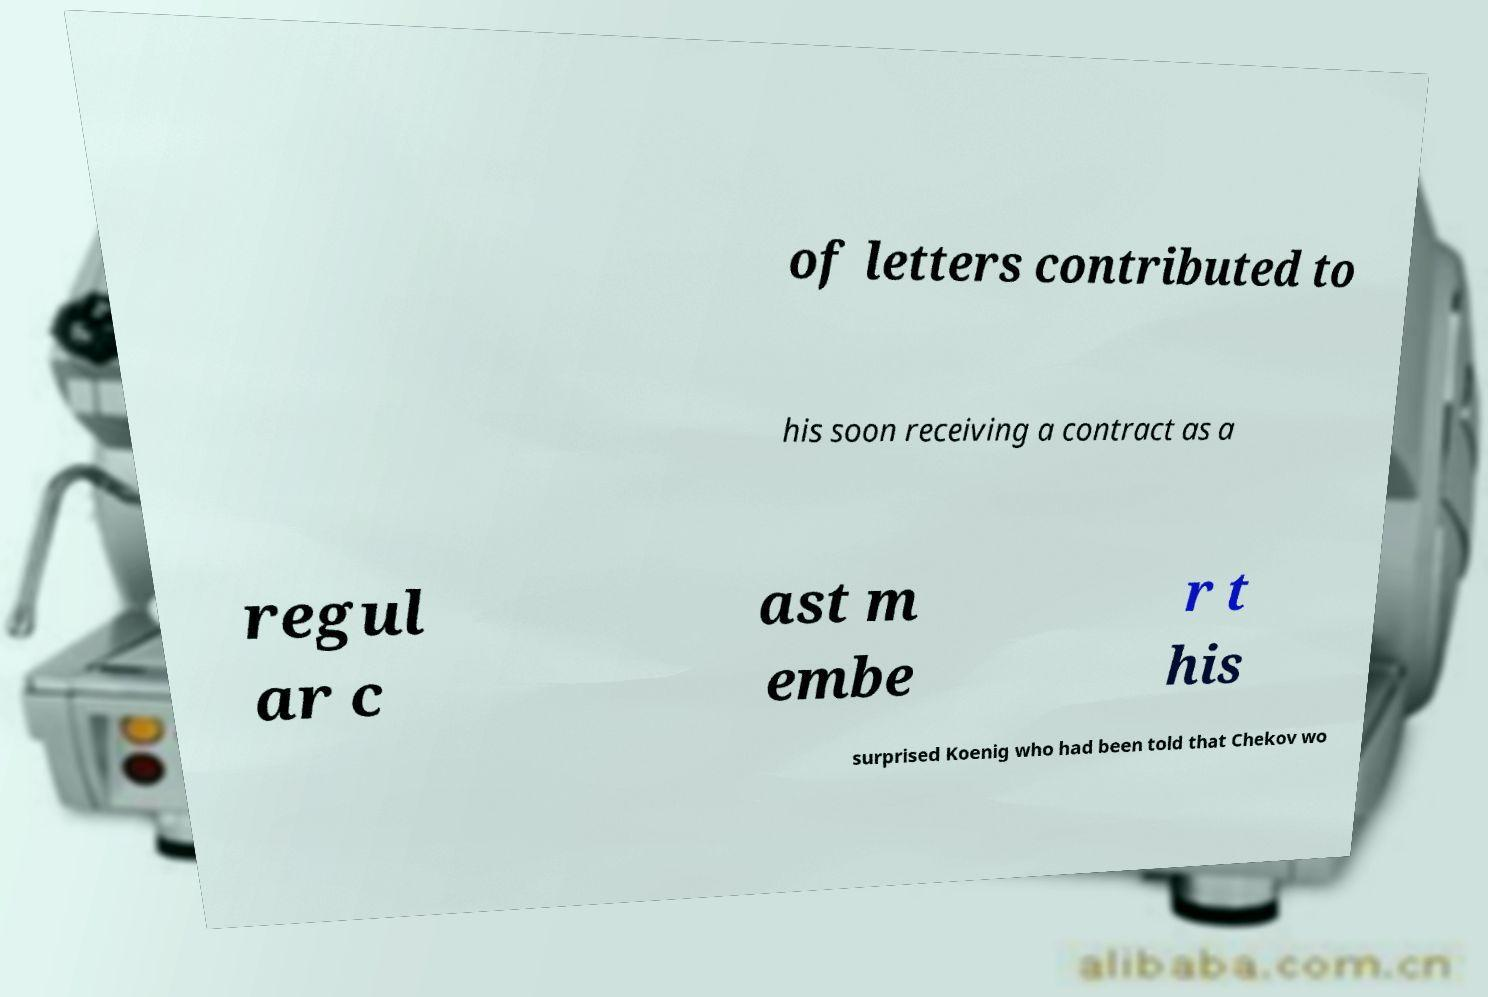For documentation purposes, I need the text within this image transcribed. Could you provide that? of letters contributed to his soon receiving a contract as a regul ar c ast m embe r t his surprised Koenig who had been told that Chekov wo 